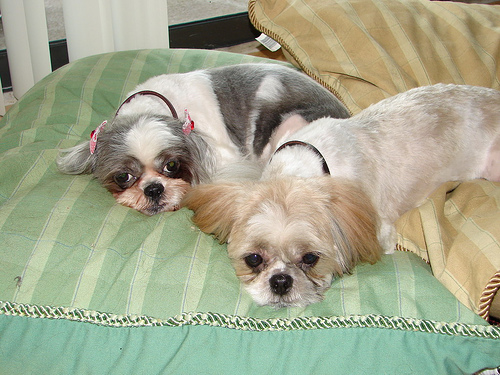<image>
Is there a dog behind the bed? No. The dog is not behind the bed. From this viewpoint, the dog appears to be positioned elsewhere in the scene. Where is the pillow in relation to the pillow? Is it on the pillow? Yes. Looking at the image, I can see the pillow is positioned on top of the pillow, with the pillow providing support. 